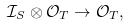<formula> <loc_0><loc_0><loc_500><loc_500>\mathcal { I } _ { S } \otimes \mathcal { O } _ { T } \to \mathcal { O } _ { T } ,</formula> 